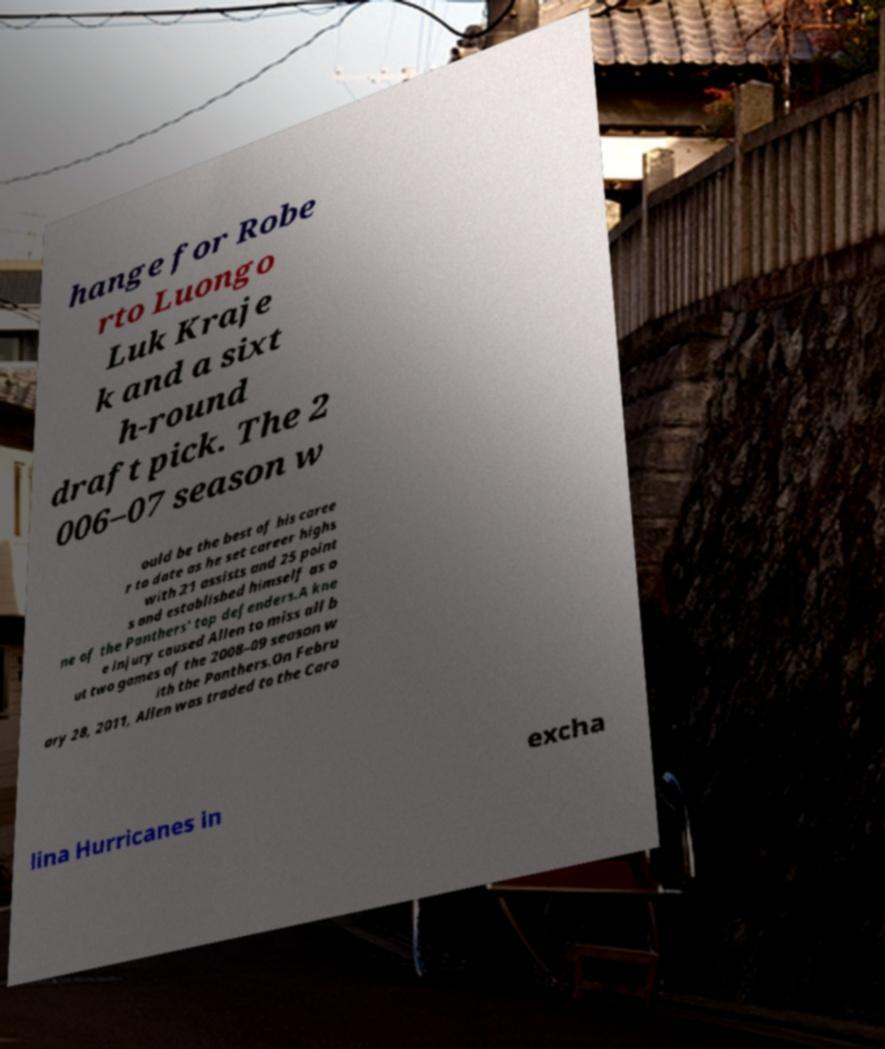Could you extract and type out the text from this image? hange for Robe rto Luongo Luk Kraje k and a sixt h-round draft pick. The 2 006–07 season w ould be the best of his caree r to date as he set career highs with 21 assists and 25 point s and established himself as o ne of the Panthers' top defenders.A kne e injury caused Allen to miss all b ut two games of the 2008–09 season w ith the Panthers.On Febru ary 28, 2011, Allen was traded to the Caro lina Hurricanes in excha 